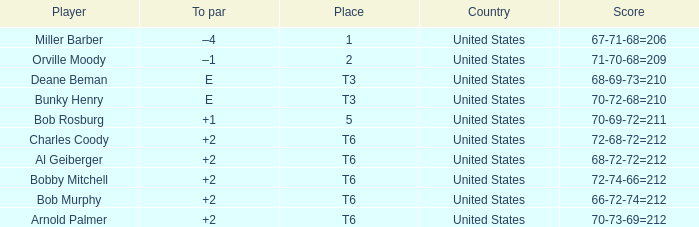What is the score of player bob rosburg? 70-69-72=211. 